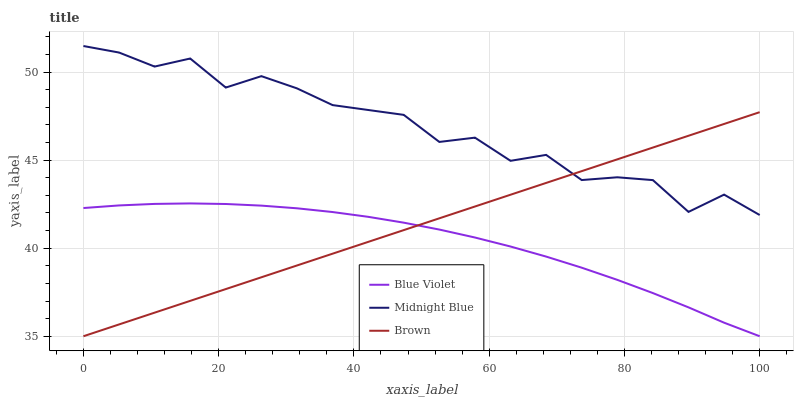Does Blue Violet have the minimum area under the curve?
Answer yes or no. Yes. Does Midnight Blue have the maximum area under the curve?
Answer yes or no. Yes. Does Midnight Blue have the minimum area under the curve?
Answer yes or no. No. Does Blue Violet have the maximum area under the curve?
Answer yes or no. No. Is Brown the smoothest?
Answer yes or no. Yes. Is Midnight Blue the roughest?
Answer yes or no. Yes. Is Blue Violet the smoothest?
Answer yes or no. No. Is Blue Violet the roughest?
Answer yes or no. No. Does Brown have the lowest value?
Answer yes or no. Yes. Does Midnight Blue have the lowest value?
Answer yes or no. No. Does Midnight Blue have the highest value?
Answer yes or no. Yes. Does Blue Violet have the highest value?
Answer yes or no. No. Is Blue Violet less than Midnight Blue?
Answer yes or no. Yes. Is Midnight Blue greater than Blue Violet?
Answer yes or no. Yes. Does Midnight Blue intersect Brown?
Answer yes or no. Yes. Is Midnight Blue less than Brown?
Answer yes or no. No. Is Midnight Blue greater than Brown?
Answer yes or no. No. Does Blue Violet intersect Midnight Blue?
Answer yes or no. No. 